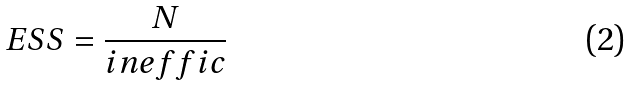<formula> <loc_0><loc_0><loc_500><loc_500>E S S = \frac { N } { i n e f f i c }</formula> 